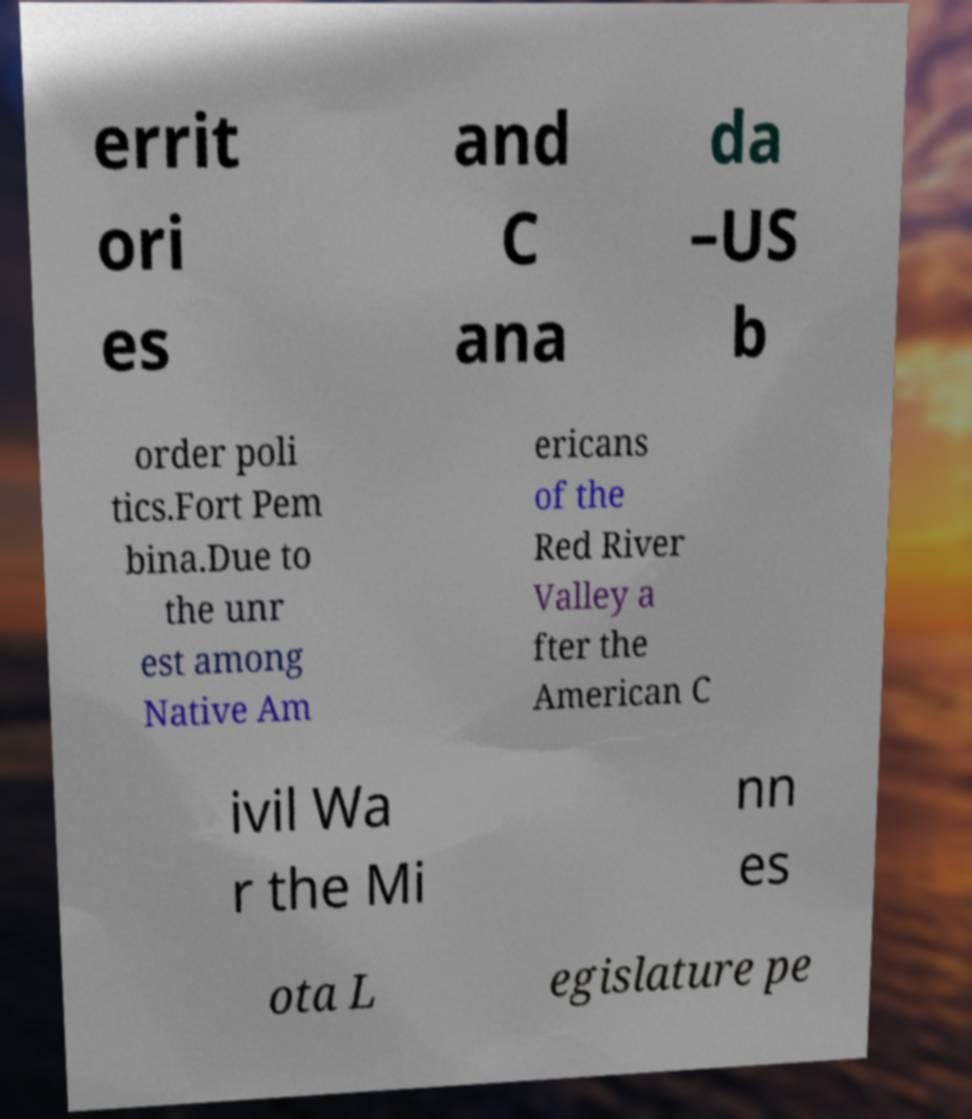What messages or text are displayed in this image? I need them in a readable, typed format. errit ori es and C ana da –US b order poli tics.Fort Pem bina.Due to the unr est among Native Am ericans of the Red River Valley a fter the American C ivil Wa r the Mi nn es ota L egislature pe 